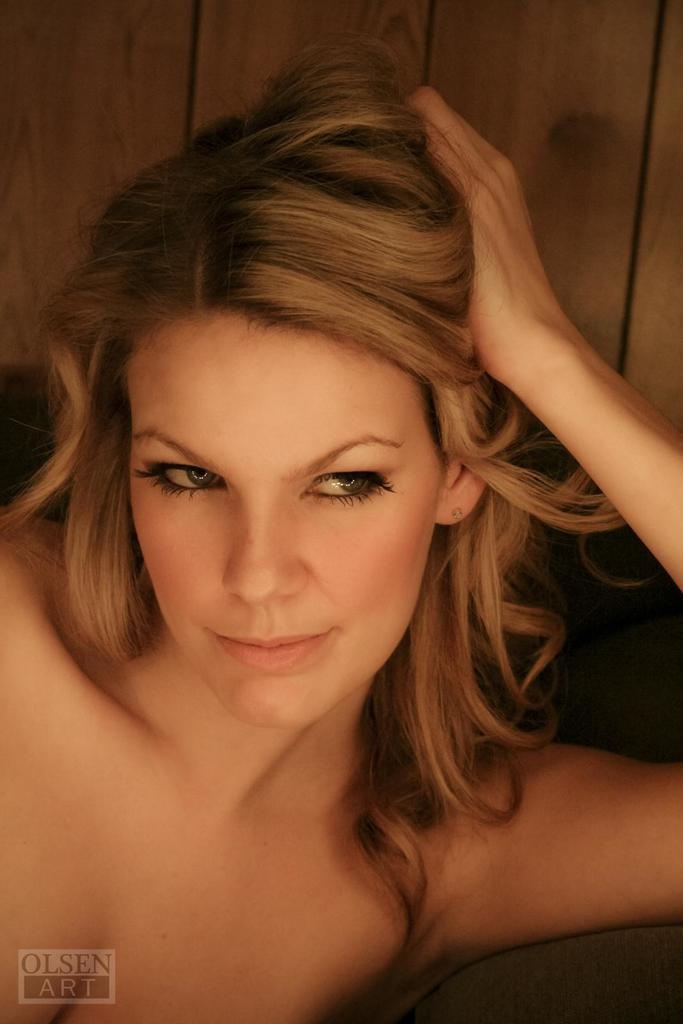Who is present in the image? There is a woman in the image. What expression does the woman have? The woman is smiling. What type of pan can be seen in the image? There is no pan present in the image; it only features a woman who is smiling. 